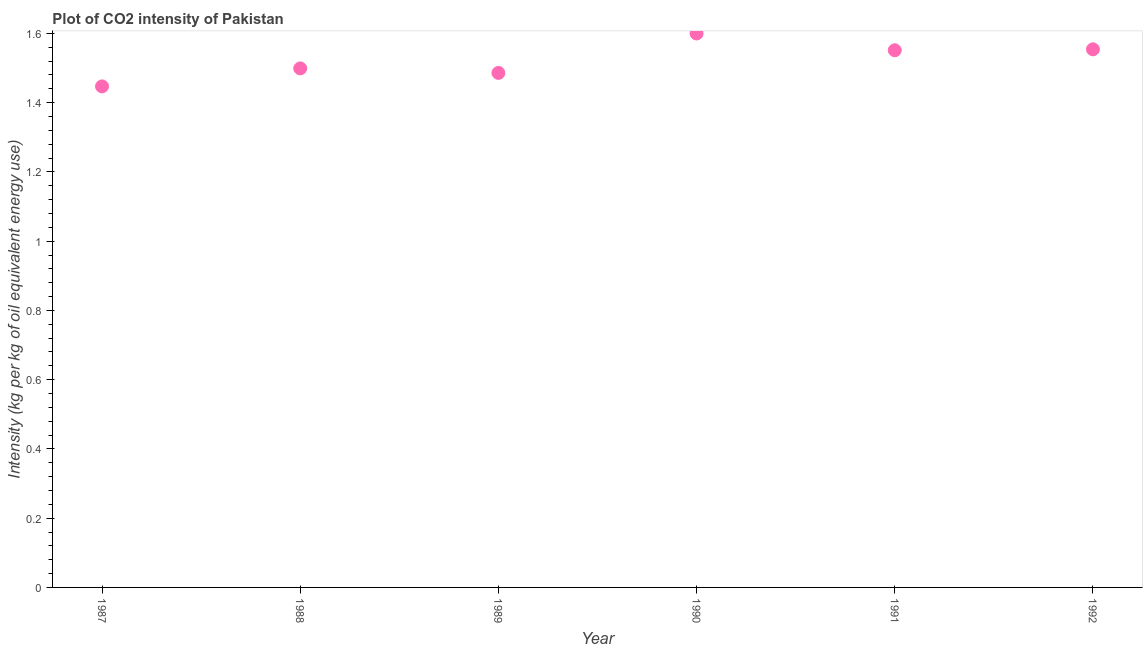What is the co2 intensity in 1990?
Provide a short and direct response. 1.6. Across all years, what is the maximum co2 intensity?
Offer a very short reply. 1.6. Across all years, what is the minimum co2 intensity?
Ensure brevity in your answer.  1.45. In which year was the co2 intensity minimum?
Provide a short and direct response. 1987. What is the sum of the co2 intensity?
Provide a succinct answer. 9.14. What is the difference between the co2 intensity in 1987 and 1988?
Offer a very short reply. -0.05. What is the average co2 intensity per year?
Ensure brevity in your answer.  1.52. What is the median co2 intensity?
Make the answer very short. 1.53. Do a majority of the years between 1992 and 1988 (inclusive) have co2 intensity greater than 0.88 kg?
Give a very brief answer. Yes. What is the ratio of the co2 intensity in 1987 to that in 1991?
Provide a succinct answer. 0.93. Is the co2 intensity in 1990 less than that in 1992?
Make the answer very short. No. What is the difference between the highest and the second highest co2 intensity?
Your response must be concise. 0.05. Is the sum of the co2 intensity in 1987 and 1991 greater than the maximum co2 intensity across all years?
Your response must be concise. Yes. What is the difference between the highest and the lowest co2 intensity?
Make the answer very short. 0.15. Does the co2 intensity monotonically increase over the years?
Your response must be concise. No. What is the difference between two consecutive major ticks on the Y-axis?
Ensure brevity in your answer.  0.2. Are the values on the major ticks of Y-axis written in scientific E-notation?
Your answer should be very brief. No. What is the title of the graph?
Provide a succinct answer. Plot of CO2 intensity of Pakistan. What is the label or title of the Y-axis?
Offer a terse response. Intensity (kg per kg of oil equivalent energy use). What is the Intensity (kg per kg of oil equivalent energy use) in 1987?
Offer a very short reply. 1.45. What is the Intensity (kg per kg of oil equivalent energy use) in 1988?
Keep it short and to the point. 1.5. What is the Intensity (kg per kg of oil equivalent energy use) in 1989?
Your response must be concise. 1.49. What is the Intensity (kg per kg of oil equivalent energy use) in 1990?
Keep it short and to the point. 1.6. What is the Intensity (kg per kg of oil equivalent energy use) in 1991?
Offer a terse response. 1.55. What is the Intensity (kg per kg of oil equivalent energy use) in 1992?
Offer a terse response. 1.55. What is the difference between the Intensity (kg per kg of oil equivalent energy use) in 1987 and 1988?
Provide a succinct answer. -0.05. What is the difference between the Intensity (kg per kg of oil equivalent energy use) in 1987 and 1989?
Your answer should be compact. -0.04. What is the difference between the Intensity (kg per kg of oil equivalent energy use) in 1987 and 1990?
Make the answer very short. -0.15. What is the difference between the Intensity (kg per kg of oil equivalent energy use) in 1987 and 1991?
Provide a short and direct response. -0.1. What is the difference between the Intensity (kg per kg of oil equivalent energy use) in 1987 and 1992?
Ensure brevity in your answer.  -0.11. What is the difference between the Intensity (kg per kg of oil equivalent energy use) in 1988 and 1989?
Provide a short and direct response. 0.01. What is the difference between the Intensity (kg per kg of oil equivalent energy use) in 1988 and 1990?
Provide a succinct answer. -0.1. What is the difference between the Intensity (kg per kg of oil equivalent energy use) in 1988 and 1991?
Your answer should be compact. -0.05. What is the difference between the Intensity (kg per kg of oil equivalent energy use) in 1988 and 1992?
Your answer should be very brief. -0.06. What is the difference between the Intensity (kg per kg of oil equivalent energy use) in 1989 and 1990?
Provide a short and direct response. -0.11. What is the difference between the Intensity (kg per kg of oil equivalent energy use) in 1989 and 1991?
Your answer should be very brief. -0.07. What is the difference between the Intensity (kg per kg of oil equivalent energy use) in 1989 and 1992?
Your answer should be compact. -0.07. What is the difference between the Intensity (kg per kg of oil equivalent energy use) in 1990 and 1991?
Your answer should be very brief. 0.05. What is the difference between the Intensity (kg per kg of oil equivalent energy use) in 1990 and 1992?
Make the answer very short. 0.05. What is the difference between the Intensity (kg per kg of oil equivalent energy use) in 1991 and 1992?
Provide a succinct answer. -0. What is the ratio of the Intensity (kg per kg of oil equivalent energy use) in 1987 to that in 1988?
Keep it short and to the point. 0.96. What is the ratio of the Intensity (kg per kg of oil equivalent energy use) in 1987 to that in 1989?
Your answer should be very brief. 0.97. What is the ratio of the Intensity (kg per kg of oil equivalent energy use) in 1987 to that in 1990?
Provide a short and direct response. 0.9. What is the ratio of the Intensity (kg per kg of oil equivalent energy use) in 1987 to that in 1991?
Ensure brevity in your answer.  0.93. What is the ratio of the Intensity (kg per kg of oil equivalent energy use) in 1987 to that in 1992?
Your answer should be compact. 0.93. What is the ratio of the Intensity (kg per kg of oil equivalent energy use) in 1988 to that in 1990?
Provide a short and direct response. 0.94. What is the ratio of the Intensity (kg per kg of oil equivalent energy use) in 1988 to that in 1992?
Ensure brevity in your answer.  0.96. What is the ratio of the Intensity (kg per kg of oil equivalent energy use) in 1989 to that in 1990?
Provide a succinct answer. 0.93. What is the ratio of the Intensity (kg per kg of oil equivalent energy use) in 1989 to that in 1991?
Make the answer very short. 0.96. What is the ratio of the Intensity (kg per kg of oil equivalent energy use) in 1989 to that in 1992?
Your answer should be very brief. 0.96. What is the ratio of the Intensity (kg per kg of oil equivalent energy use) in 1990 to that in 1991?
Your answer should be very brief. 1.03. What is the ratio of the Intensity (kg per kg of oil equivalent energy use) in 1991 to that in 1992?
Make the answer very short. 1. 